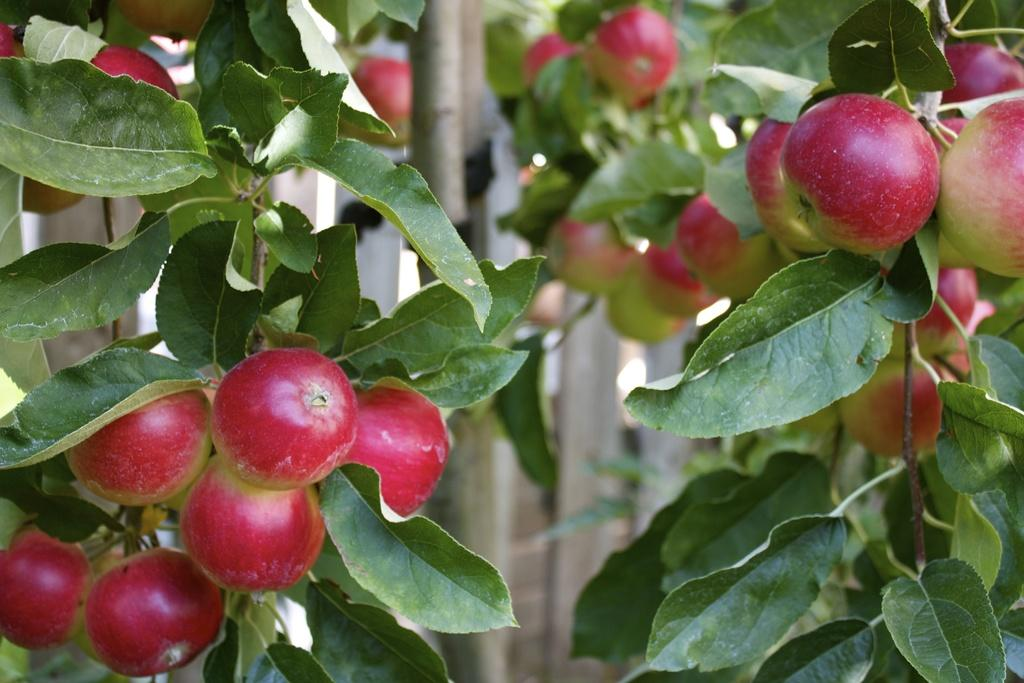What type of fruit can be seen on the tree in the image? There are many apples on the tree in the image. What else can be seen at the bottom of the tree? There are leaves at the bottom of the tree in the image. What type of material is the fencing visible in the background made of? The wooden fencing is visible in the background of the image. How many plastic kittens are sitting on the fence in the image? There are no plastic kittens present in the image. 